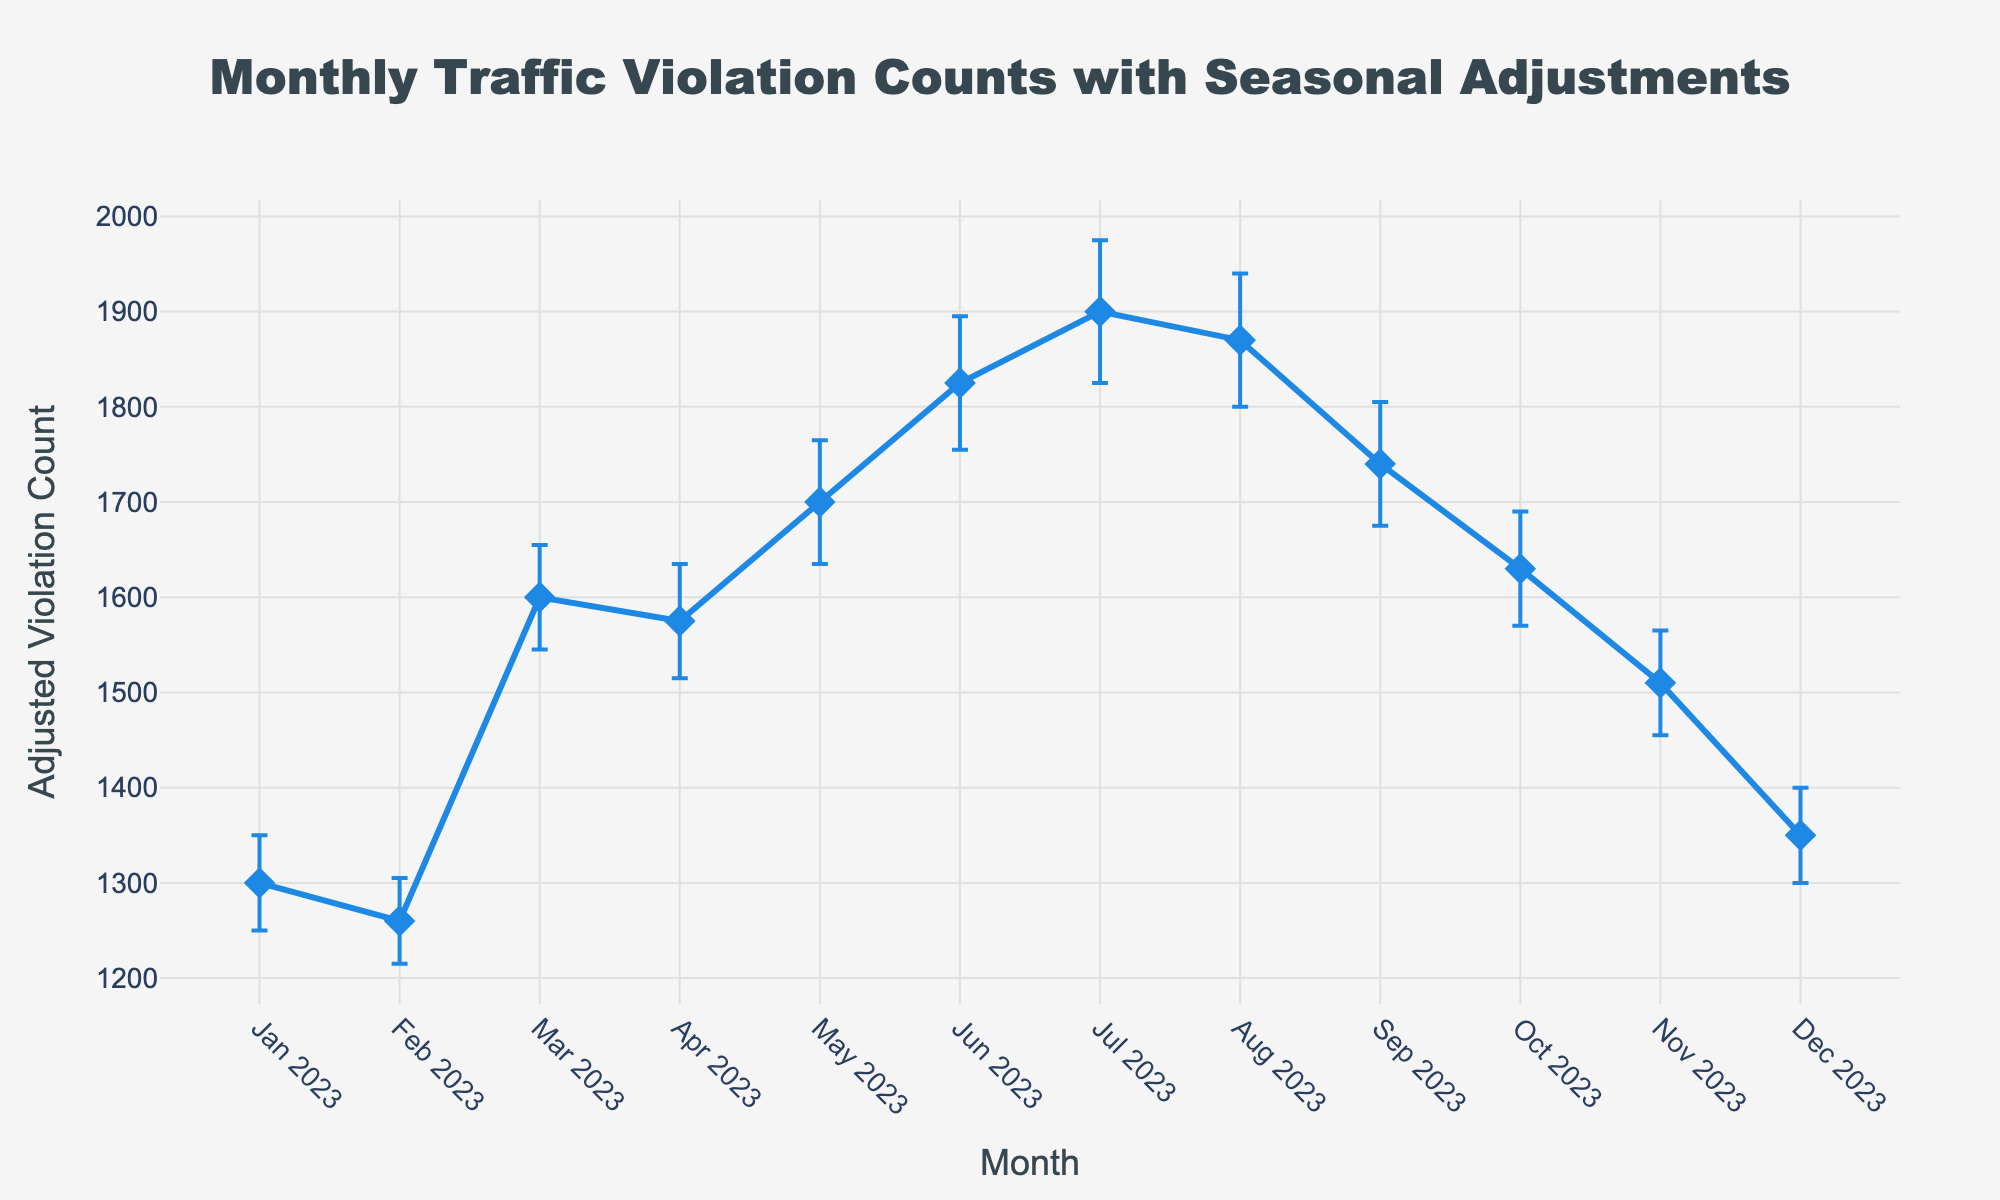What is the title of the plot? The title is located at the top of the plot. It provides an overview of what the plot represents.
Answer: Monthly Traffic Violation Counts with Seasonal Adjustments What are the x-axis and y-axis titles? The x-axis title is below the x-axis and the y-axis title is to the left of the y-axis. They describe the respective axes.
Answer: Month (x-axis), Adjusted Violation Count (y-axis) How many data points are shown in the plot? Count the number of distinct points along the plotted line. Each point represents one month.
Answer: 12 Which month has the highest Adjusted Violation Count? Look for the highest point on the y-axis and identify the corresponding month on the x-axis.
Answer: July 2023 What is the Adjusted Violation Count for January 2023? Find the data point for January 2023 on the x-axis and read the corresponding value on the y-axis.
Answer: 1300 What is the difference in Adjusted Violation Count between January 2023 and July 2023? Subtract the January 2023 Adjusted Violation Count from the July 2023 Adjusted Violation Count.
Answer: 1900 - 1300 = 600, so the difference is 600 Which month has the largest error margin? Identify the month with the longest error bar.
Answer: July 2023 Which months have a higher Adjusted Violation Count than the average Adjusted Violation Count? Calculate the average Adjusted Violation Count, then identify the months with counts above this average. The average is (1300 + 1260 + 1600 + 1575 + 1700 + 1825 + 1900 + 1870 + 1740 + 1630 + 1510 + 1350) / 12 = 1596.
Answer: April 2023, May 2023, June 2023, July 2023, August 2023, September 2023 What is the pattern of Adjusted Violation Counts from January to December 2023? Describe the general trend by observing the values across the months.
Answer: The counts are relatively low at the beginning of the year, peak in the summer (June and July), and then decrease towards the end of the year Which month had the largest increase in Adjusted Violation Count compared to the previous month? Calculate the monthly changes and identify the largest increase. From Jan to Feb: 1260 - 1300 = -40; Feb to Mar: 1600 - 1260 = 340; ...; Jun to Jul: 1900 - 1825 = 75. The largest increase is from February to March by 340.
Answer: March 2023 